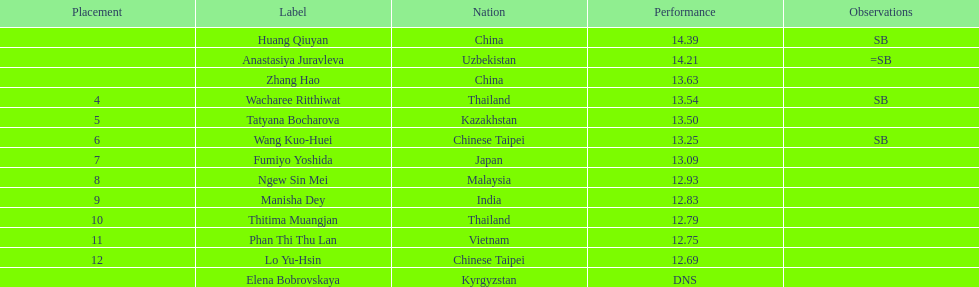What was the average result of the top three jumpers? 14.08. 